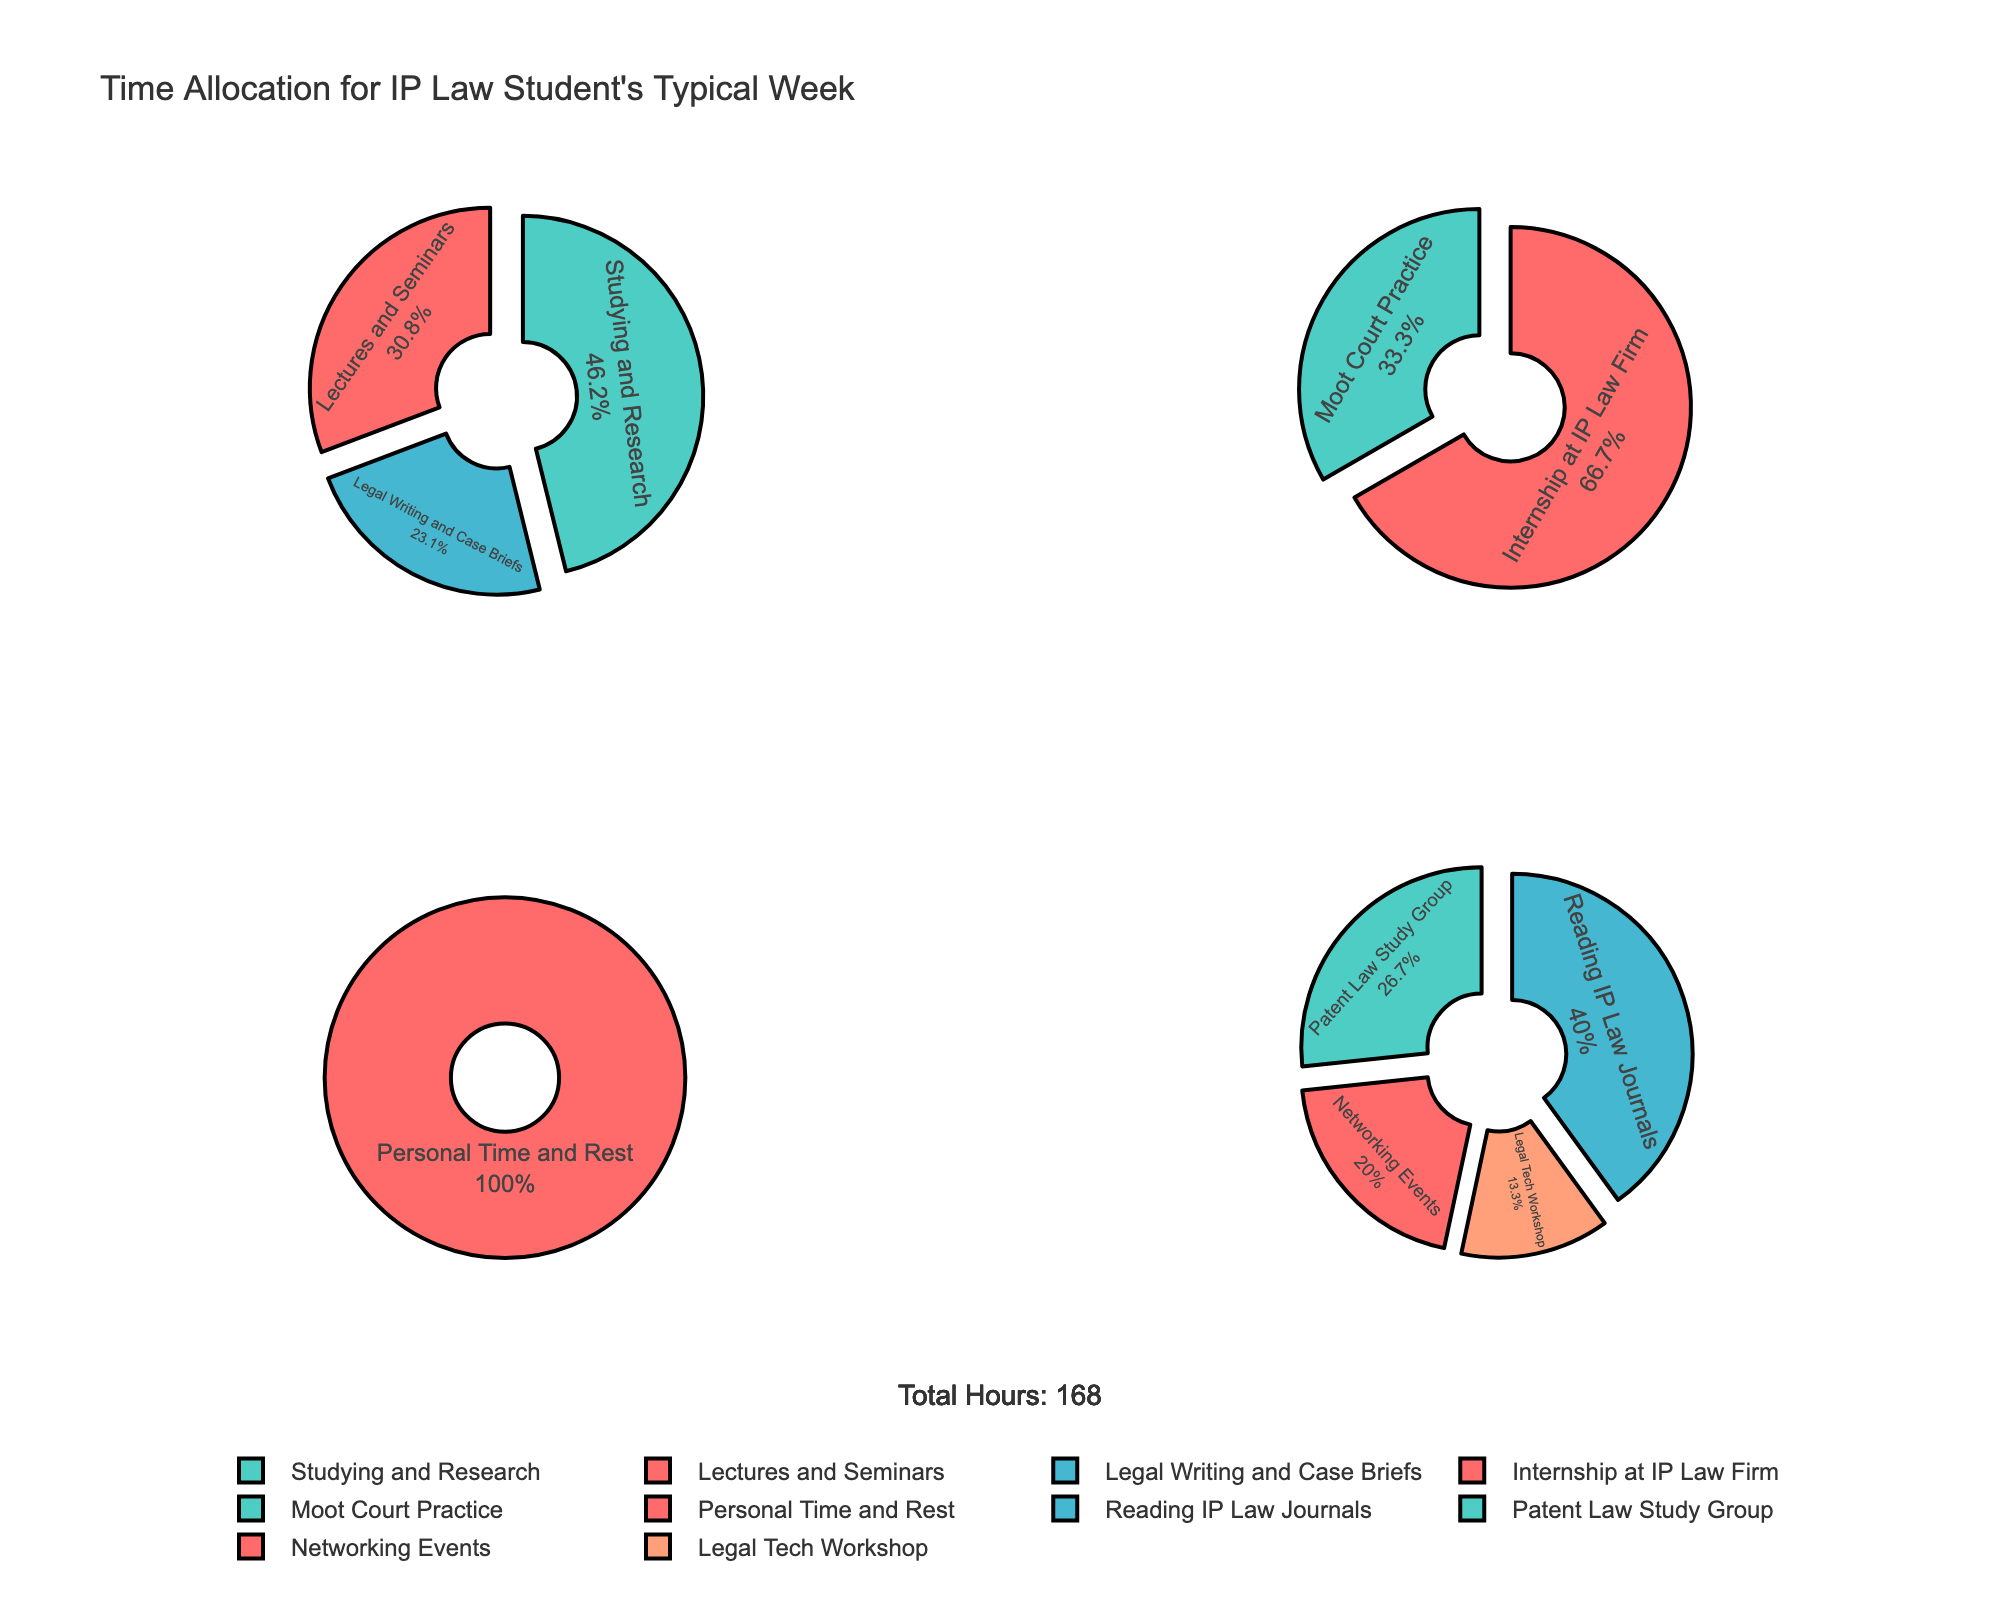What is the title of the subplot figure? The title is typically displayed at the top of the figure, summarizing its content. It provides an overview of what the figure is about.
Answer: "Employee Volunteering Hours by Company Size and Industry" How many subplots are there and what industries do they represent? The figure is divided into four subplots, each representing different industry sectors. The subplot titles are provided in the figure: Technology, Finance, Retail, and Others.
Answer: Four; Technology, Finance, Retail, Others Which subplot has the highest volunteering hours for any company? By examining all four subplots, we can identify that the Retail subplot contains Walmart with 500,000 volunteering hours, which is the highest amongst all companies.
Answer: Retail What is the general relationship between company size and volunteering hours? Observing the scatter plots across all subplots, there seems to be a loose positive correlation indicating that larger companies tend to have more volunteering hours. However, there are exceptions.
Answer: Generally positive correlation Which sector contains the company with the smallest volunteering hours in the `Others` subplot? The Others subplot contains all industries not classified under Technology, Finance, or Retail. By examining this subplot, we find ExxonMobil in the Energy sector has the smallest volunteering hours at 25,000.
Answer: Energy What color represents the Technology sector? Each sector is represented by a different color in the figure. The Technology sector is shown in a blueish color.
Answer: Blue Compare the volunteering hours between IBM and Google in the Technology subplot. In the Technology subplot, identify IBM and Google. IBM has 120,000 volunteering hours, while Google has 110,000 volunteering hours. Thus, IBM has more volunteering hours than Google.
Answer: IBM has more Which company in the Finance subplot has the highest volunteering hours, and how many? By checking the Finance subplot, JPMorgan Chase has the highest volunteering hours in this subplot with 180,000 hours.
Answer: JPMorgan Chase; 180,000 hours Is the size of Starbucks bigger than the size of Amazon? How do their volunteering hours compare? In the Retail subplot, compare the points representing Starbucks and Amazon. Starbucks has 350,000 employees and Amazon has 1,300,000 employees. Look at their volunteering hours, Starbucks has 300,000 and Amazon has 400,000.
Answer: No; Amazon has more volunteering hours 